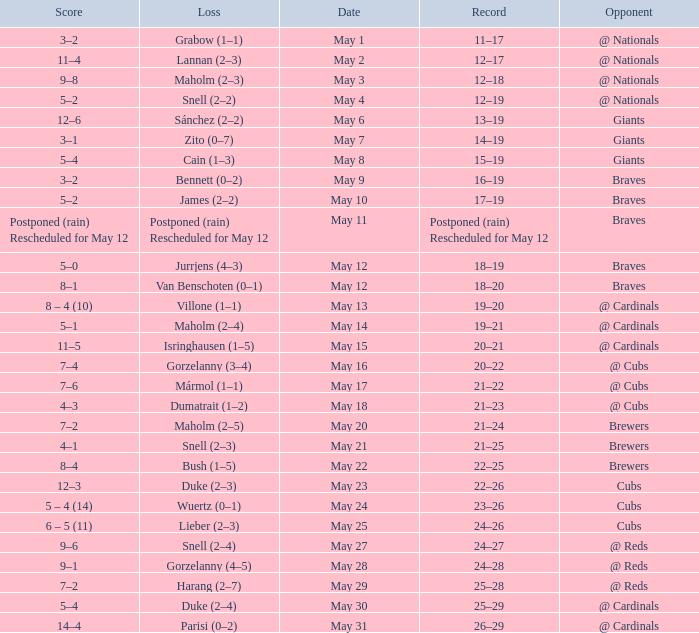What was the score of the game with a loss of Maholm (2–4)? 5–1. 